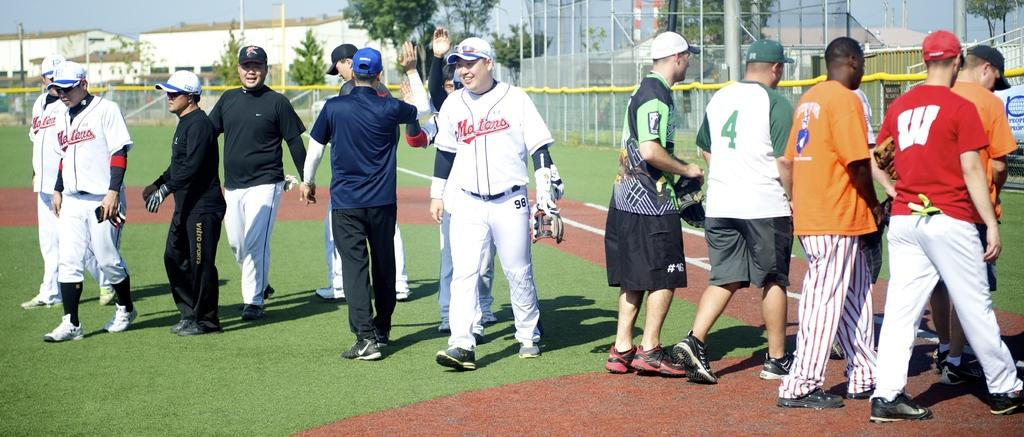<image>
Render a clear and concise summary of the photo. The Maters baseball team walking out onto the field as people in casual clothes walk off. 